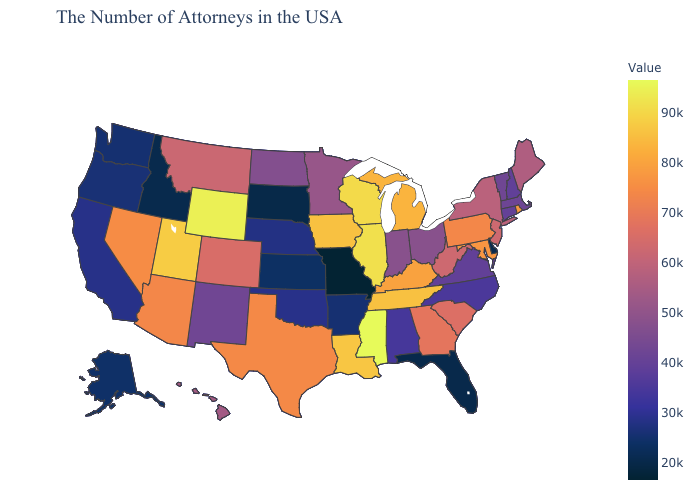Does the map have missing data?
Write a very short answer. No. Among the states that border Texas , which have the lowest value?
Keep it brief. Arkansas. Which states have the lowest value in the USA?
Write a very short answer. Missouri. Does Oregon have a higher value than Texas?
Quick response, please. No. 